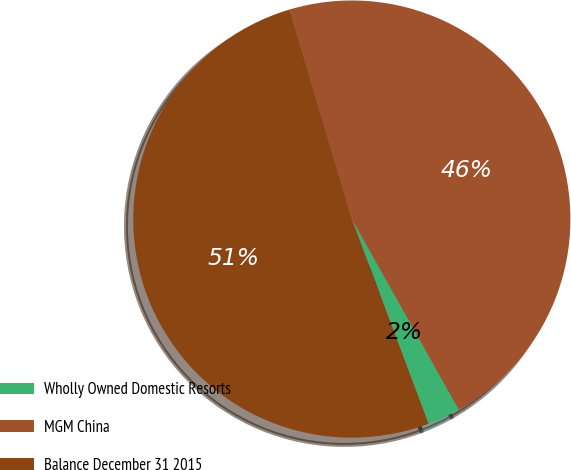Convert chart. <chart><loc_0><loc_0><loc_500><loc_500><pie_chart><fcel>Wholly Owned Domestic Resorts<fcel>MGM China<fcel>Balance December 31 2015<nl><fcel>2.43%<fcel>46.46%<fcel>51.11%<nl></chart> 